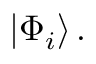Convert formula to latex. <formula><loc_0><loc_0><loc_500><loc_500>\left | \Phi _ { i } \right \rangle .</formula> 